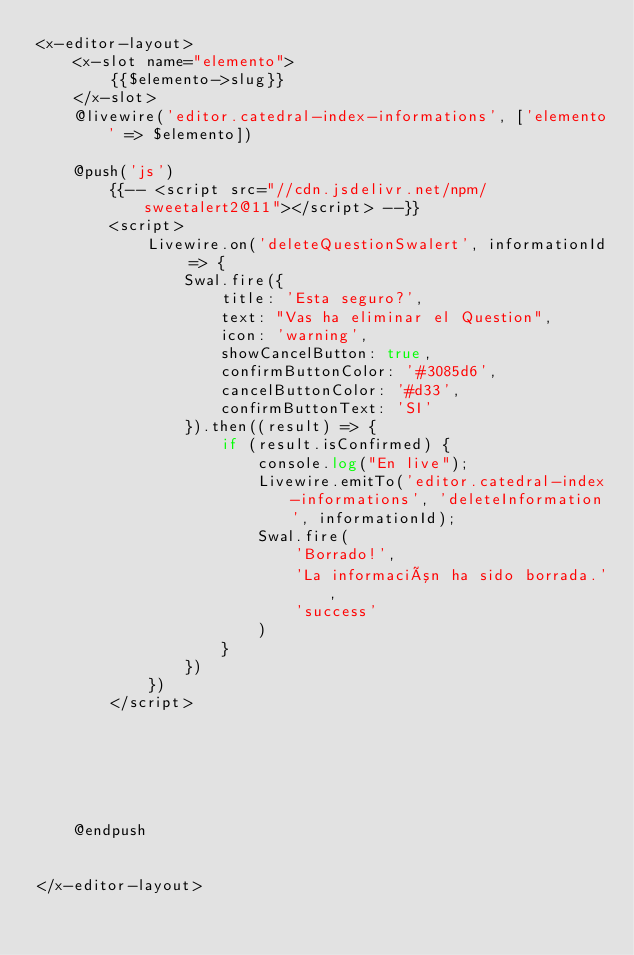<code> <loc_0><loc_0><loc_500><loc_500><_PHP_><x-editor-layout>
    <x-slot name="elemento">
        {{$elemento->slug}}
    </x-slot>
    @livewire('editor.catedral-index-informations', ['elemento' => $elemento])

    @push('js')
        {{-- <script src="//cdn.jsdelivr.net/npm/sweetalert2@11"></script> --}}
        <script>
            Livewire.on('deleteQuestionSwalert', informationId => {
                Swal.fire({
                    title: 'Esta seguro?',
                    text: "Vas ha eliminar el Question",
                    icon: 'warning',
                    showCancelButton: true,
                    confirmButtonColor: '#3085d6',
                    cancelButtonColor: '#d33',
                    confirmButtonText: 'SI'
                }).then((result) => {
                    if (result.isConfirmed) {
                        console.log("En live");
                        Livewire.emitTo('editor.catedral-index-informations', 'deleteInformation', informationId);
                        Swal.fire(
                            'Borrado!',
                            'La información ha sido borrada.',
                            'success'
                        )
                    }
                })
            })
        </script>






    @endpush


</x-editor-layout>


</code> 